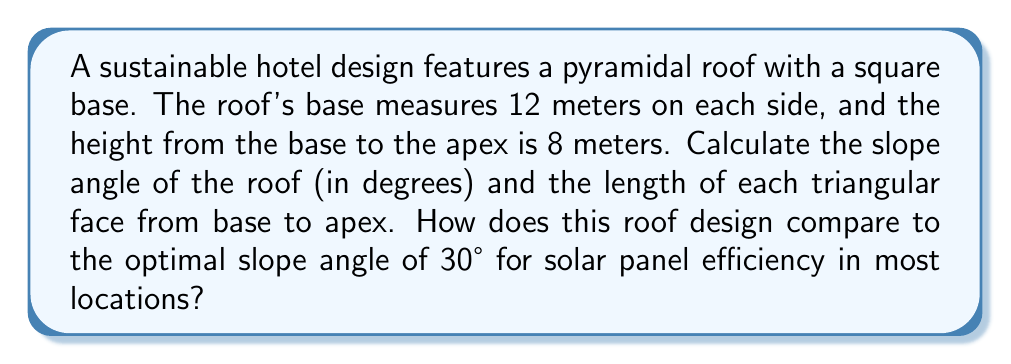Can you answer this question? Let's approach this problem step-by-step:

1) First, we need to visualize the pyramid. The base is a 12m × 12m square, and the height is 8m.

2) To find the slope angle, we need to consider a right triangle formed by:
   - Half of the base diagonal (hypotenuse of the base triangle)
   - The height of the pyramid
   - The slant height (from corner to apex)

3) Let's calculate half of the base diagonal:
   $$\text{Half diagonal} = \frac{\sqrt{12^2 + 12^2}}{2} = \frac{12\sqrt{2}}{2} = 6\sqrt{2} \approx 8.49\text{ m}$$

4) Now we have a right triangle with:
   - Base = $6\sqrt{2}$ m
   - Height = 8 m

5) The slope angle θ can be calculated using the tangent function:
   $$\tan(\theta) = \frac{8}{6\sqrt{2}}$$

6) To get θ, we use the inverse tangent (arctan):
   $$\theta = \arctan(\frac{8}{6\sqrt{2}}) \approx 40.0°$$

7) For the length of each triangular face, we can use the Pythagorean theorem:
   $$\text{Face length} = \sqrt{8^2 + (6\sqrt{2})^2} = \sqrt{64 + 72} = \sqrt{136} \approx 11.66\text{ m}$$

8) Comparing to the optimal 30° angle for solar panels:
   The roof slope (40.0°) is steeper than the optimal angle, which might reduce solar panel efficiency slightly but could be beneficial for shedding rain or snow.

[asy]
import geometry;

size(200);

pair A = (0,0), B = (6,0), C = (3,4), D = (3,0);
draw(A--B--C--cycle);
draw(D--C,dashed);
label("8m",D--C,W);
label("6√2m",A--B,S);
label("θ",(2.8,0.2),NE);
label("11.66m",A--C,NW);
[/asy]
Answer: The slope angle of the roof is approximately 40.0°, and the length of each triangular face from base to apex is approximately 11.66 meters. This roof design has a steeper angle than the optimal 30° for solar panels, which may slightly reduce efficiency but could offer other benefits such as better water runoff. 